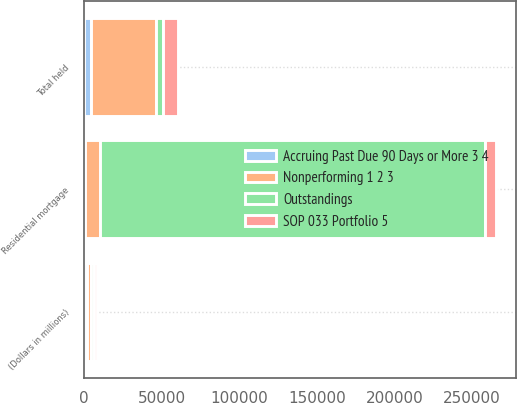Convert chart to OTSL. <chart><loc_0><loc_0><loc_500><loc_500><stacked_bar_chart><ecel><fcel>(Dollars in millions)<fcel>Residential mortgage<fcel>Total held<nl><fcel>Outstandings<fcel>2008<fcel>247999<fcel>4311<nl><fcel>SOP 033 Portfolio 5<fcel>2008<fcel>7044<fcel>9908<nl><fcel>Accruing Past Due 90 Days or More 3 4<fcel>2008<fcel>372<fcel>4311<nl><fcel>Nonperforming 1 2 3<fcel>2008<fcel>9949<fcel>42209<nl></chart> 